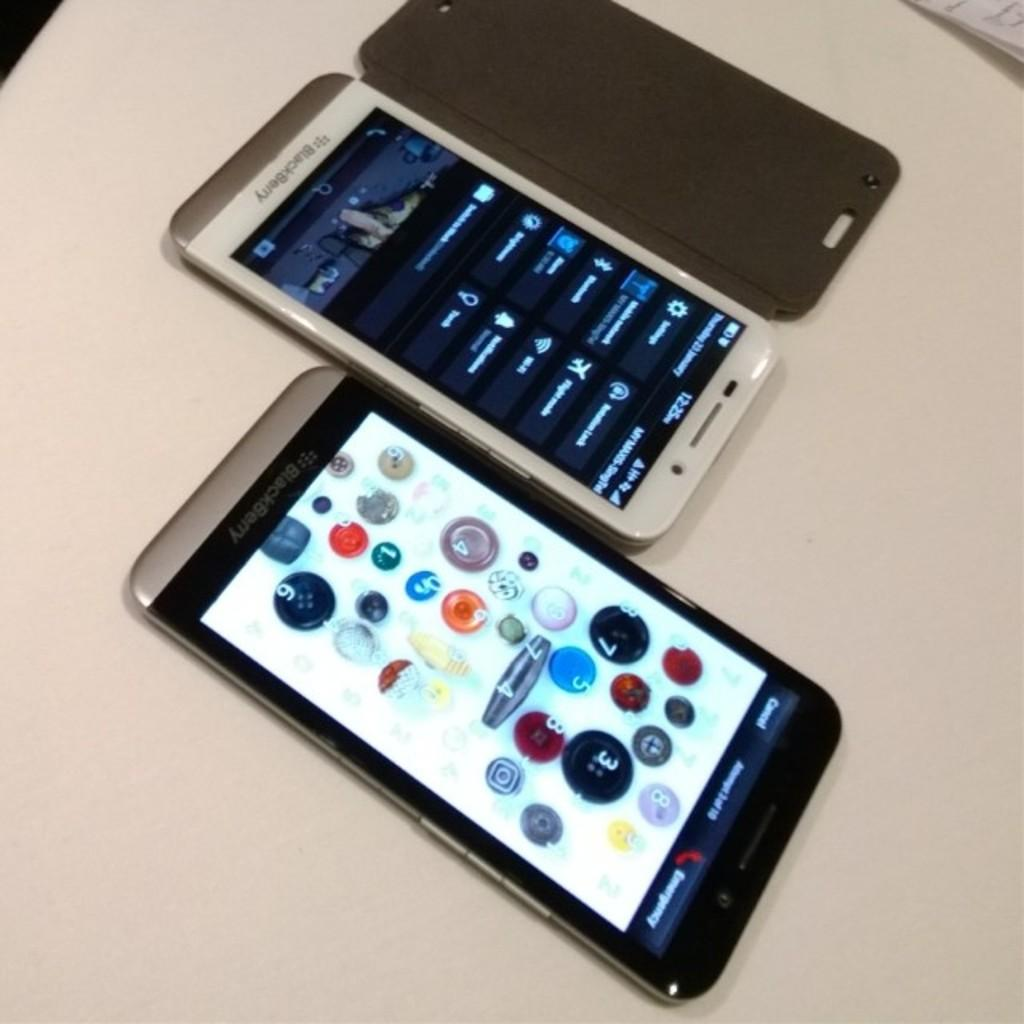What objects are present in the image? There are mobiles in the image. Where are the mobiles located? The mobiles are placed on a table. What type of education is being provided by the mobiles in the image? The mobiles in the image are not providing any education, as they are inanimate objects. 